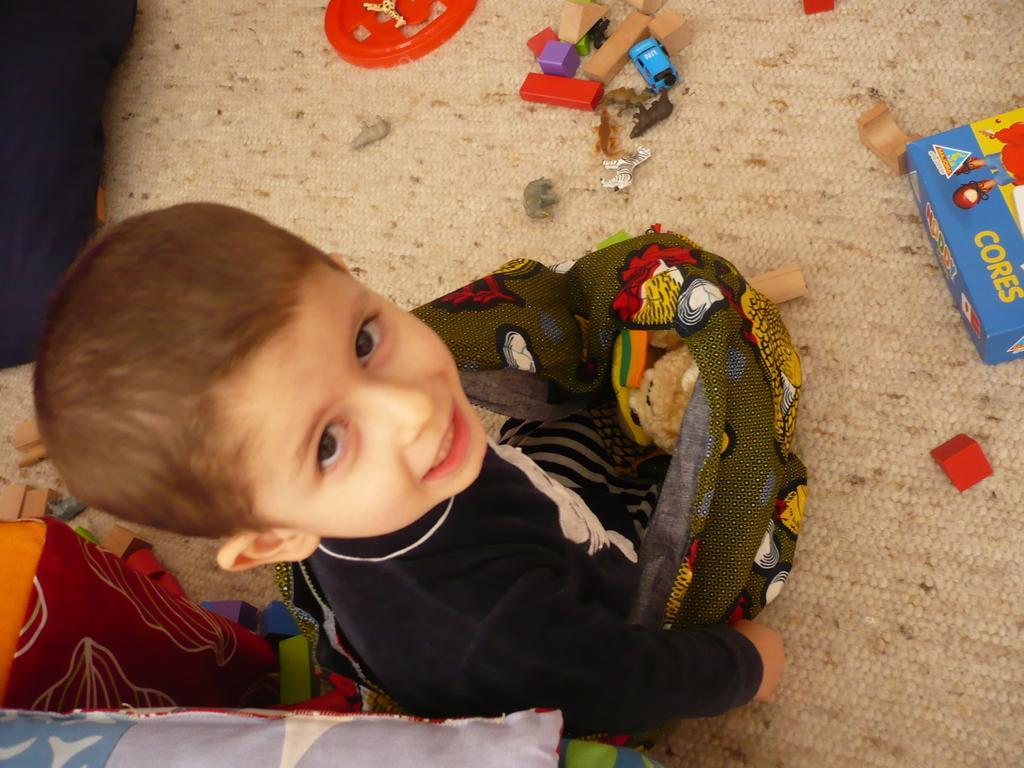Please provide a concise description of this image. There is a small boy holding some objects in the foreground, there are toys and other objects on the floor. 